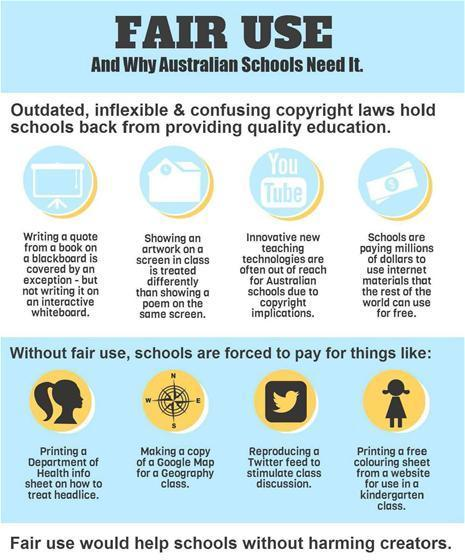What materials can the rest of the world use for free?
Answer the question with a short phrase. internet materials. What is the reason innovative new teaching technologies are often out of reach for Australian schools? Copyright Implications. 